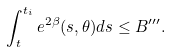<formula> <loc_0><loc_0><loc_500><loc_500>\int _ { t } ^ { t _ { i } } e ^ { 2 \beta } ( s , \theta ) d s \leq B ^ { \prime \prime \prime } .</formula> 